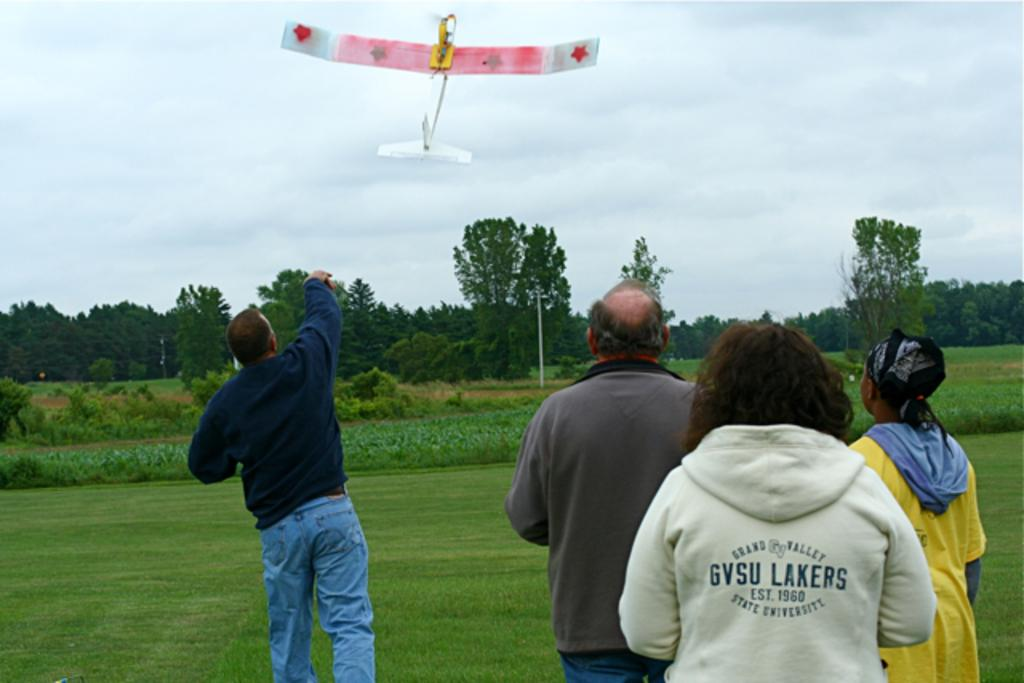<image>
Provide a brief description of the given image. A woman wearing a GVSU Lakers sweater watches a man throw a model plane. 